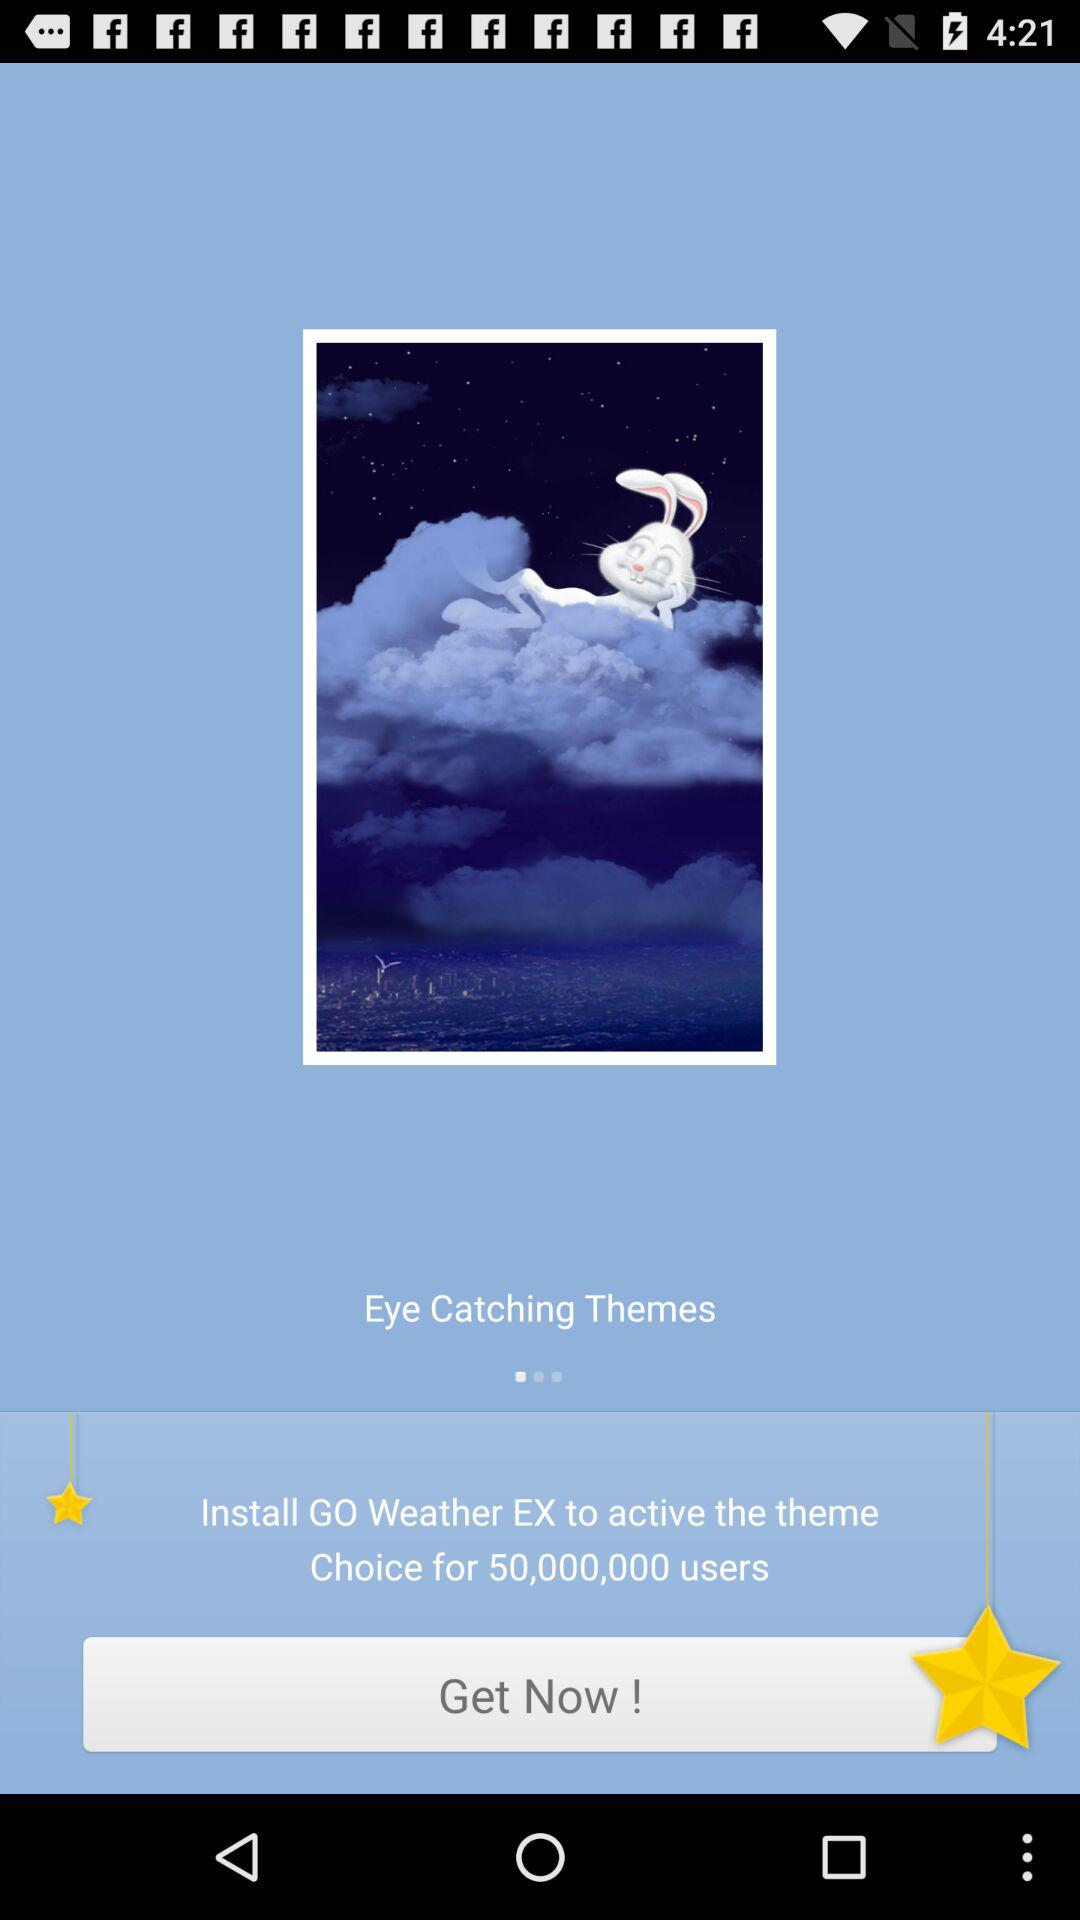What application should I download to activate the theme? You should download "GO Weather EX" to activate the theme. 